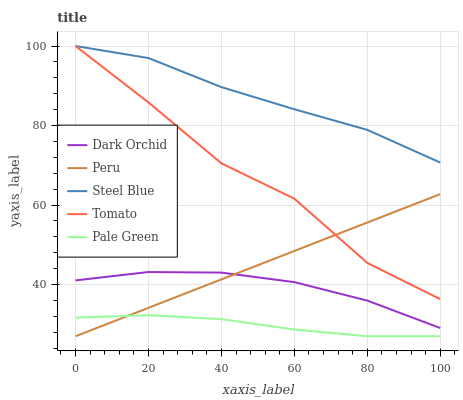Does Peru have the minimum area under the curve?
Answer yes or no. No. Does Peru have the maximum area under the curve?
Answer yes or no. No. Is Pale Green the smoothest?
Answer yes or no. No. Is Pale Green the roughest?
Answer yes or no. No. Does Dark Orchid have the lowest value?
Answer yes or no. No. Does Peru have the highest value?
Answer yes or no. No. Is Pale Green less than Steel Blue?
Answer yes or no. Yes. Is Tomato greater than Pale Green?
Answer yes or no. Yes. Does Pale Green intersect Steel Blue?
Answer yes or no. No. 